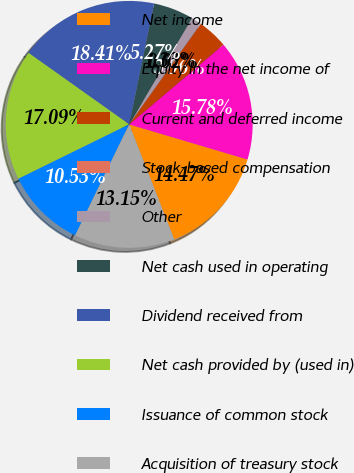Convert chart. <chart><loc_0><loc_0><loc_500><loc_500><pie_chart><fcel>Net income<fcel>Equity in the net income of<fcel>Current and deferred income<fcel>Stock-based compensation<fcel>Other<fcel>Net cash used in operating<fcel>Dividend received from<fcel>Net cash provided by (used in)<fcel>Issuance of common stock<fcel>Acquisition of treasury stock<nl><fcel>14.47%<fcel>15.78%<fcel>3.96%<fcel>0.02%<fcel>1.33%<fcel>5.27%<fcel>18.41%<fcel>17.09%<fcel>10.53%<fcel>13.15%<nl></chart> 